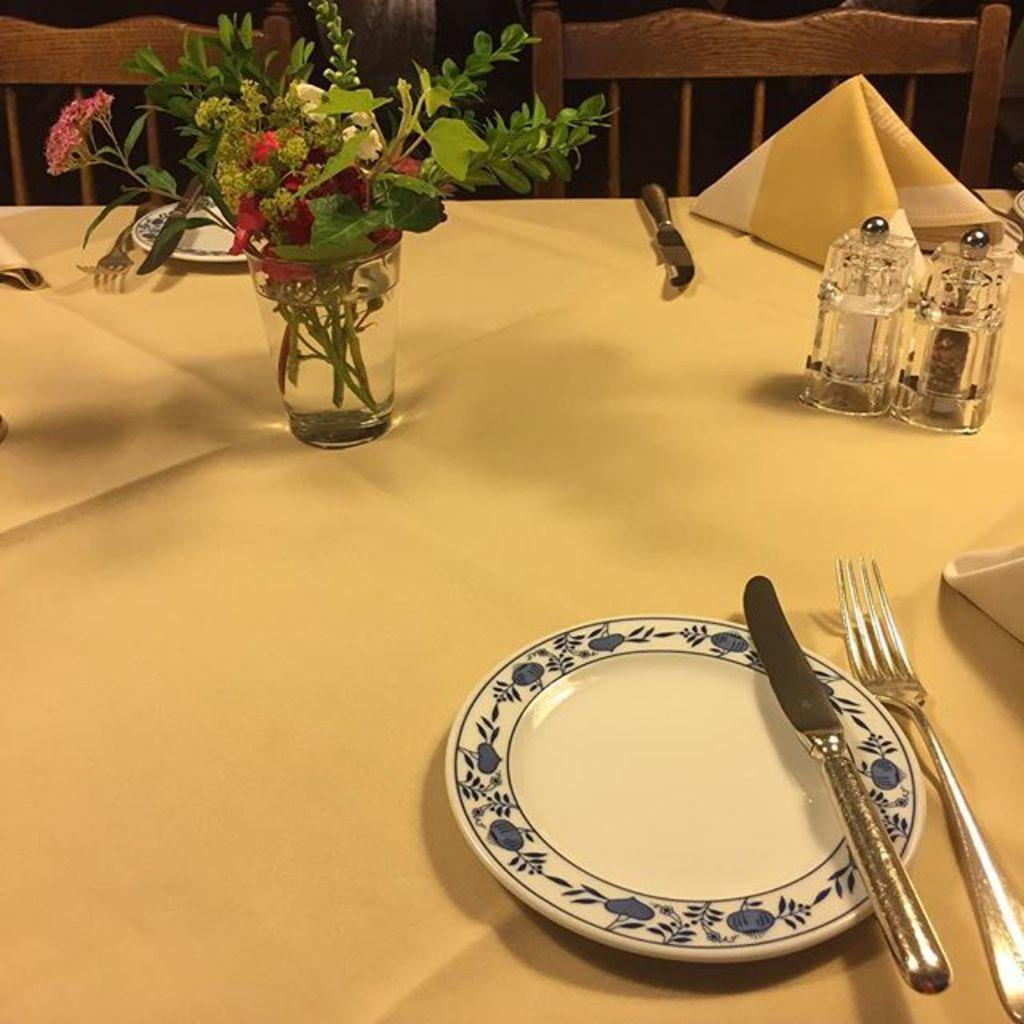What is covering the table in the image? There is a table covered with a cloth in the image. What can be seen on top of the tablecloth? A glass, plates, spoons, and napkins are present on the table. Are there any other objects on the table? Yes, there are other objects on the table. How many chairs are visible in the image? There are two chairs at the top of the image. What type of knowledge can be gained from the cracker on the table? There is no cracker present on the table in the image, so no knowledge can be gained from it. 